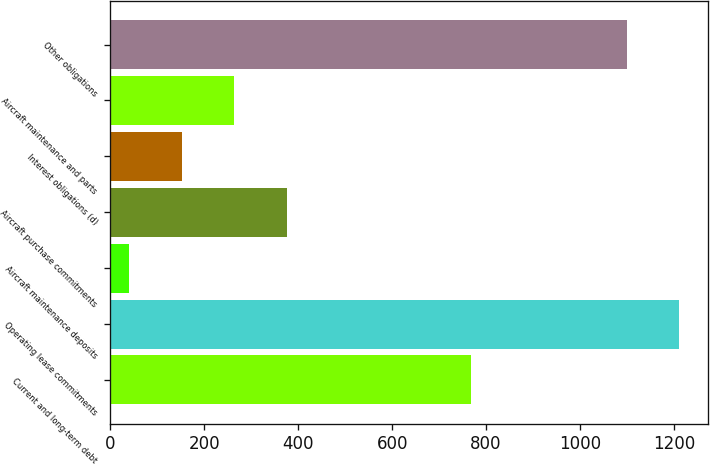Convert chart. <chart><loc_0><loc_0><loc_500><loc_500><bar_chart><fcel>Current and long-term debt<fcel>Operating lease commitments<fcel>Aircraft maintenance deposits<fcel>Aircraft purchase commitments<fcel>Interest obligations (d)<fcel>Aircraft maintenance and parts<fcel>Other obligations<nl><fcel>768<fcel>1211.4<fcel>39<fcel>376.2<fcel>151.4<fcel>263.8<fcel>1099<nl></chart> 